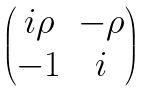<formula> <loc_0><loc_0><loc_500><loc_500>\begin{pmatrix} i \rho & - \rho \\ - 1 & i \end{pmatrix}</formula> 